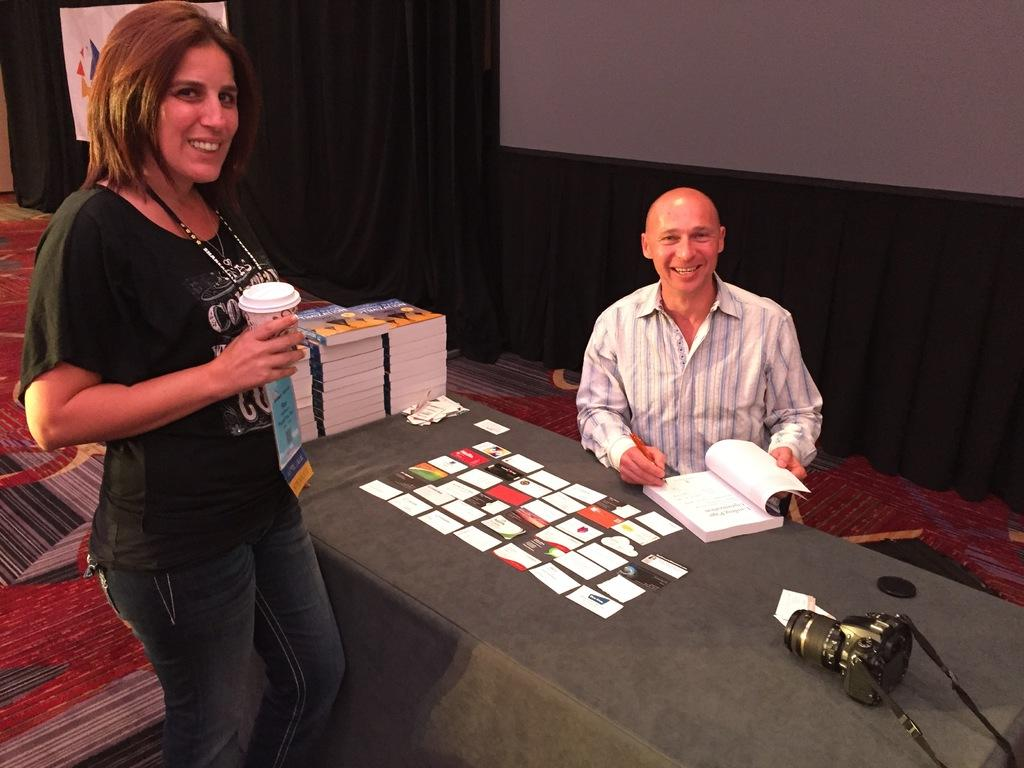What is present in the image that can be used to cover a window or doorway? There is a curtain in the image. How many people are visible in the image? There are two people in the image. What piece of furniture is present in the image? There is a table in the image. What items can be seen on the table? There is a book, papers, and a camera on the table. Where is the farm located in the image? There is no farm present in the image. How many children are playing in the image? There is no mention of children or any play activity in the image. 